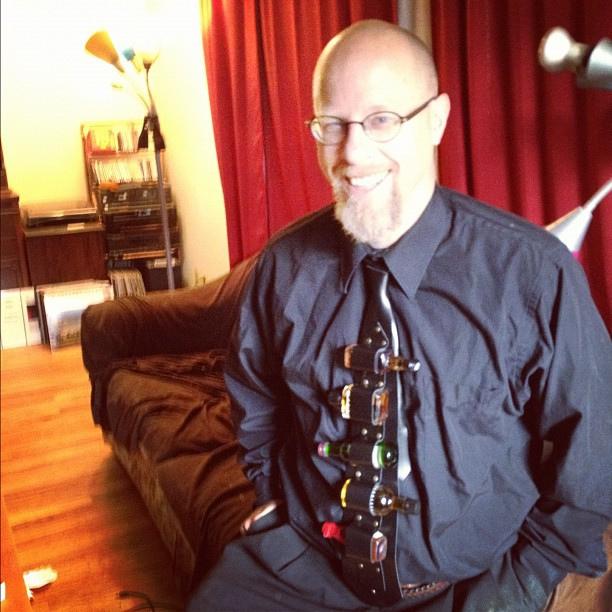What is on the man's tie?
Be succinct. Bottles. Does this person have natural hair?
Concise answer only. Yes. Does this guy appear healthy?
Keep it brief. Yes. What is the man sitting on?
Short answer required. Couch. 